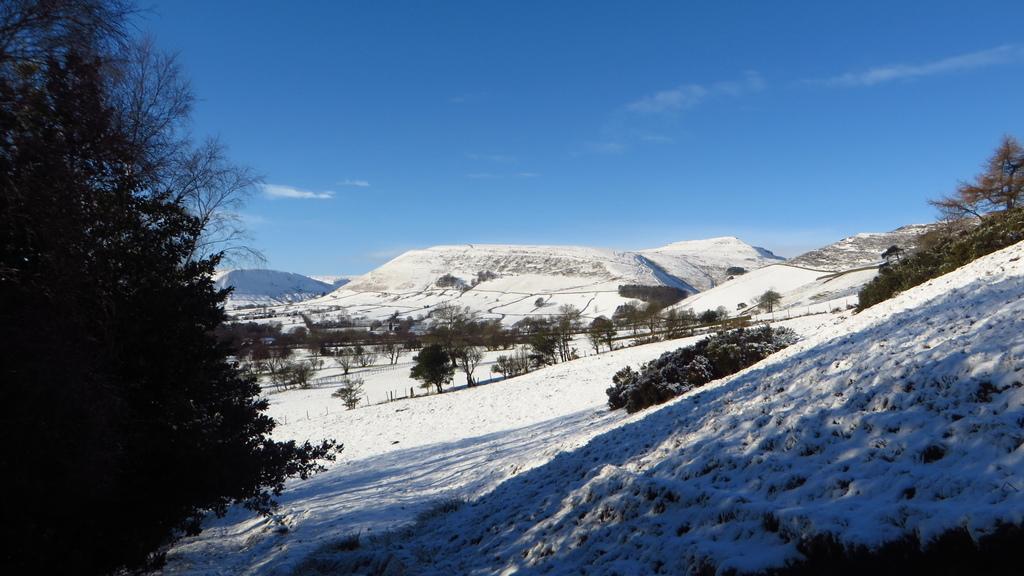How would you summarize this image in a sentence or two? In this image there are snow mountains in the middle. On the left side there is a tree. In between the mountains there are trees in the snow. At the top there is the sky. 